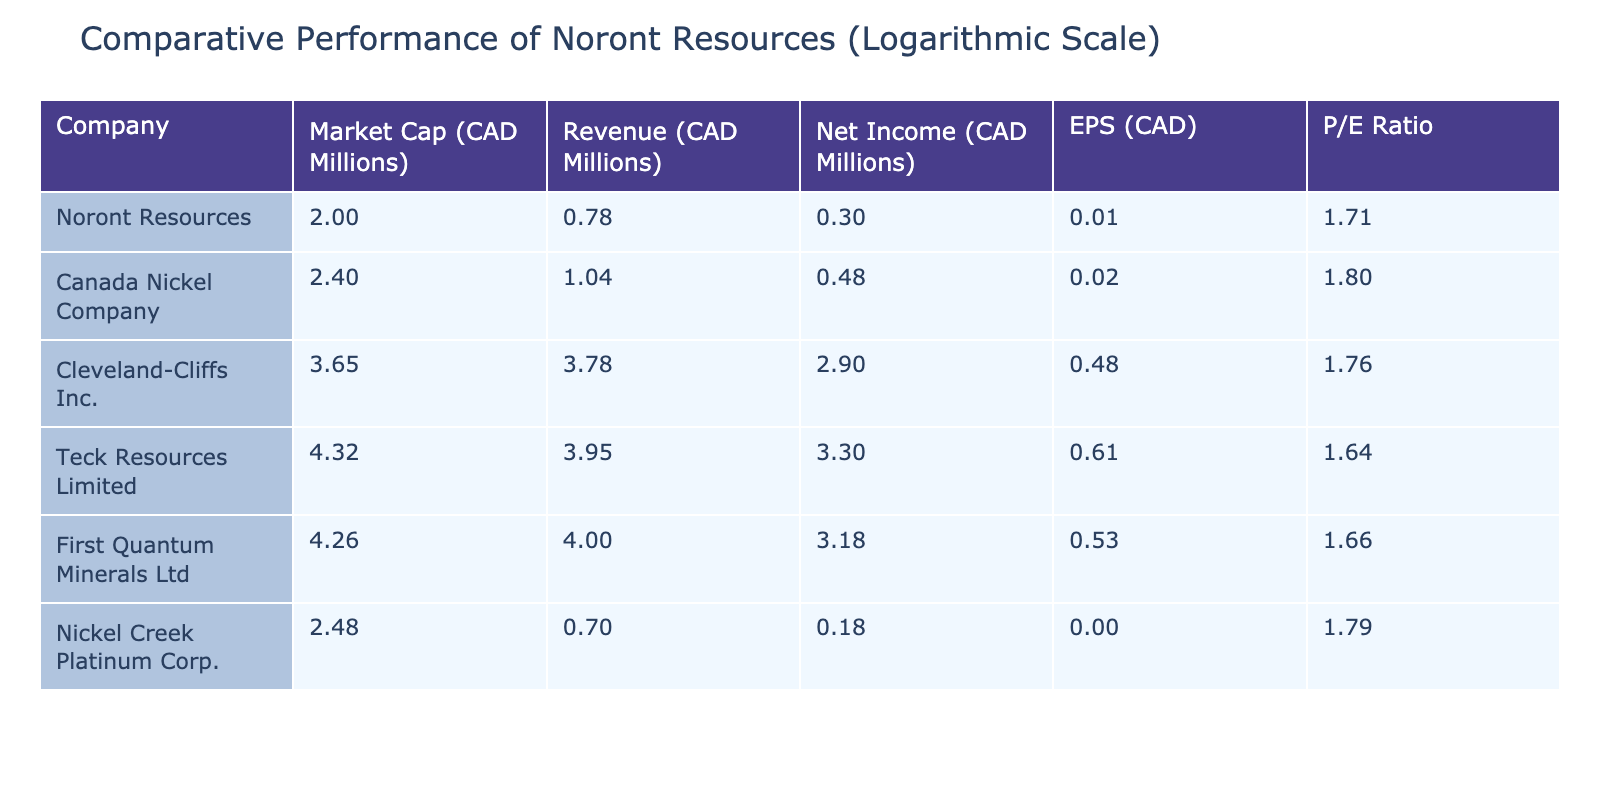What is the market capitalization of Noront Resources? The table shows that the market capitalization of Noront Resources is listed under the "Market Cap (CAD Millions)" column, where the value is 100.
Answer: 100 How much revenue did Teck Resources Limited generate? Referring to the "Revenue (CAD Millions)" column in the table, the revenue for Teck Resources Limited is 9000.
Answer: 9000 Is Noront Resources' net income higher than that of Nickel Creek Platinum Corp.? Noront Resources has a net income of 1, while Nickel Creek Platinum Corp. has a net income of 0.5. Since 1 is greater than 0.5, the statement is true.
Answer: Yes What is the average EPS of the companies listed in the table? To find the average EPS, sum the EPS values (0.02 + 0.04 + 2.00 + 3.10 + 2.40 + 0.01) = 7.57, then divide by the number of companies (6). So, the average EPS is 7.57 / 6 ≈ 1.26.
Answer: 1.26 Which company has the highest P/E ratio? By examining the "P/E Ratio" column, we find that Cleveland-Cliffs Inc. has the highest P/E ratio at 56.25 compared to others in the table.
Answer: Cleveland-Cliffs Inc Which company has a lower net income, Noront Resources or Canada Nickel Company? Noront Resources has a net income of 1, while Canada Nickel Company has a net income of 2. Since 1 is less than 2, Noront Resources has a lower net income.
Answer: Yes What is the difference in market capitalization between Teck Resources Limited and Cleveland-Cliffs Inc.? Teck Resources Limited has a market capitalization of 21000, and Cleveland-Cliffs Inc. has 4500. The difference is 21000 - 4500 = 16500.
Answer: 16500 How many companies have a net income greater than 1? Checking the "Net Income (CAD Millions)" column, we see that both Cleveland-Cliffs Inc. (800) and Teck Resources Limited (2000) have net incomes greater than 1, making a total of 3 companies.
Answer: 3 What is the ratio of Noront Resources' market capitalization to that of First Quantum Minerals Ltd? Noront Resources has a market capitalization of 100, and First Quantum Minerals Ltd has 18000. The ratio is 100 / 18000 = 0.00556, or roughly 1:180.
Answer: 1:180 